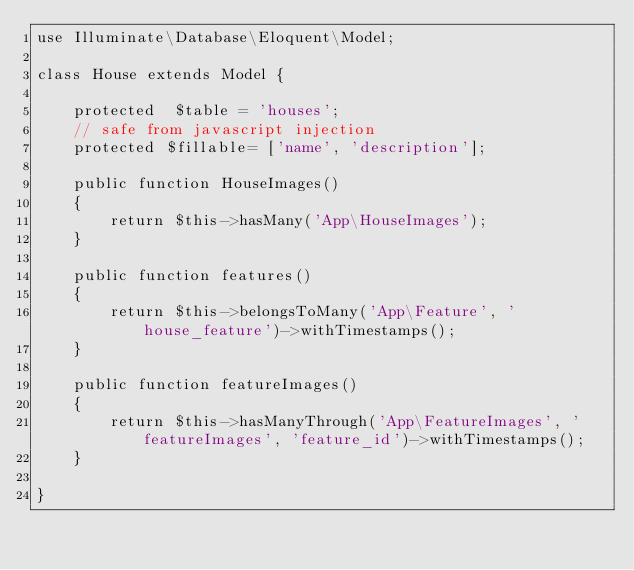<code> <loc_0><loc_0><loc_500><loc_500><_PHP_>use Illuminate\Database\Eloquent\Model;

class House extends Model {

    protected  $table = 'houses';
    // safe from javascript injection
    protected $fillable= ['name', 'description'];

    public function HouseImages()
    {
        return $this->hasMany('App\HouseImages');
    }

    public function features()
    {
        return $this->belongsToMany('App\Feature', 'house_feature')->withTimestamps();
    }

    public function featureImages()
    {
        return $this->hasManyThrough('App\FeatureImages', 'featureImages', 'feature_id')->withTimestamps();
    }

}
</code> 